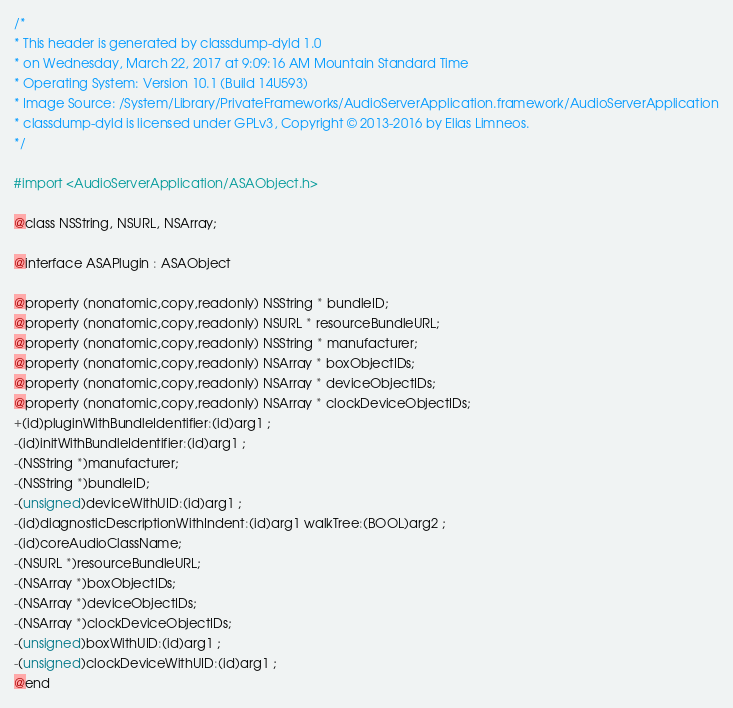<code> <loc_0><loc_0><loc_500><loc_500><_C_>/*
* This header is generated by classdump-dyld 1.0
* on Wednesday, March 22, 2017 at 9:09:16 AM Mountain Standard Time
* Operating System: Version 10.1 (Build 14U593)
* Image Source: /System/Library/PrivateFrameworks/AudioServerApplication.framework/AudioServerApplication
* classdump-dyld is licensed under GPLv3, Copyright © 2013-2016 by Elias Limneos.
*/

#import <AudioServerApplication/ASAObject.h>

@class NSString, NSURL, NSArray;

@interface ASAPlugin : ASAObject

@property (nonatomic,copy,readonly) NSString * bundleID; 
@property (nonatomic,copy,readonly) NSURL * resourceBundleURL; 
@property (nonatomic,copy,readonly) NSString * manufacturer; 
@property (nonatomic,copy,readonly) NSArray * boxObjectIDs; 
@property (nonatomic,copy,readonly) NSArray * deviceObjectIDs; 
@property (nonatomic,copy,readonly) NSArray * clockDeviceObjectIDs; 
+(id)pluginWithBundleIdentifier:(id)arg1 ;
-(id)initWithBundleIdentifier:(id)arg1 ;
-(NSString *)manufacturer;
-(NSString *)bundleID;
-(unsigned)deviceWithUID:(id)arg1 ;
-(id)diagnosticDescriptionWithIndent:(id)arg1 walkTree:(BOOL)arg2 ;
-(id)coreAudioClassName;
-(NSURL *)resourceBundleURL;
-(NSArray *)boxObjectIDs;
-(NSArray *)deviceObjectIDs;
-(NSArray *)clockDeviceObjectIDs;
-(unsigned)boxWithUID:(id)arg1 ;
-(unsigned)clockDeviceWithUID:(id)arg1 ;
@end

</code> 